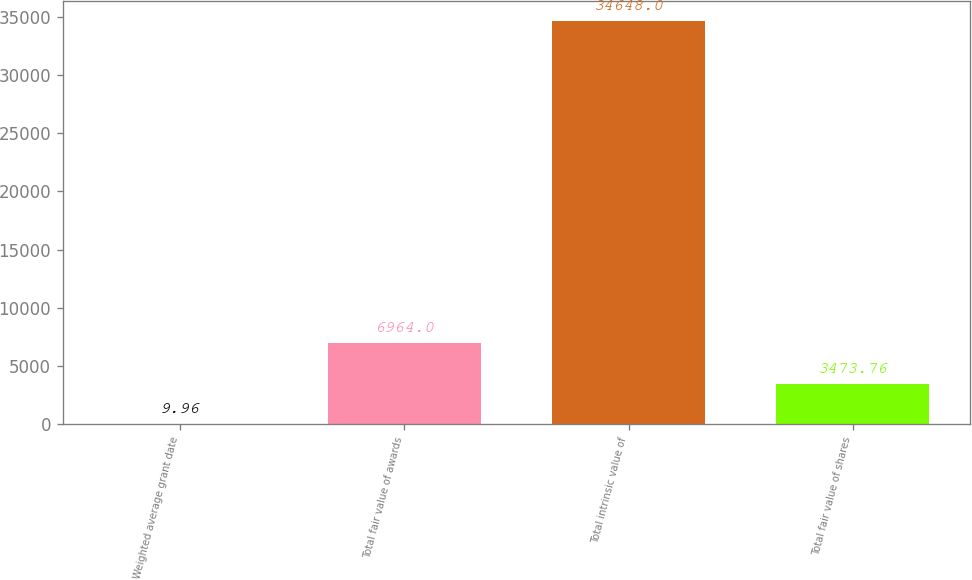Convert chart. <chart><loc_0><loc_0><loc_500><loc_500><bar_chart><fcel>Weighted average grant date<fcel>Total fair value of awards<fcel>Total intrinsic value of<fcel>Total fair value of shares<nl><fcel>9.96<fcel>6964<fcel>34648<fcel>3473.76<nl></chart> 